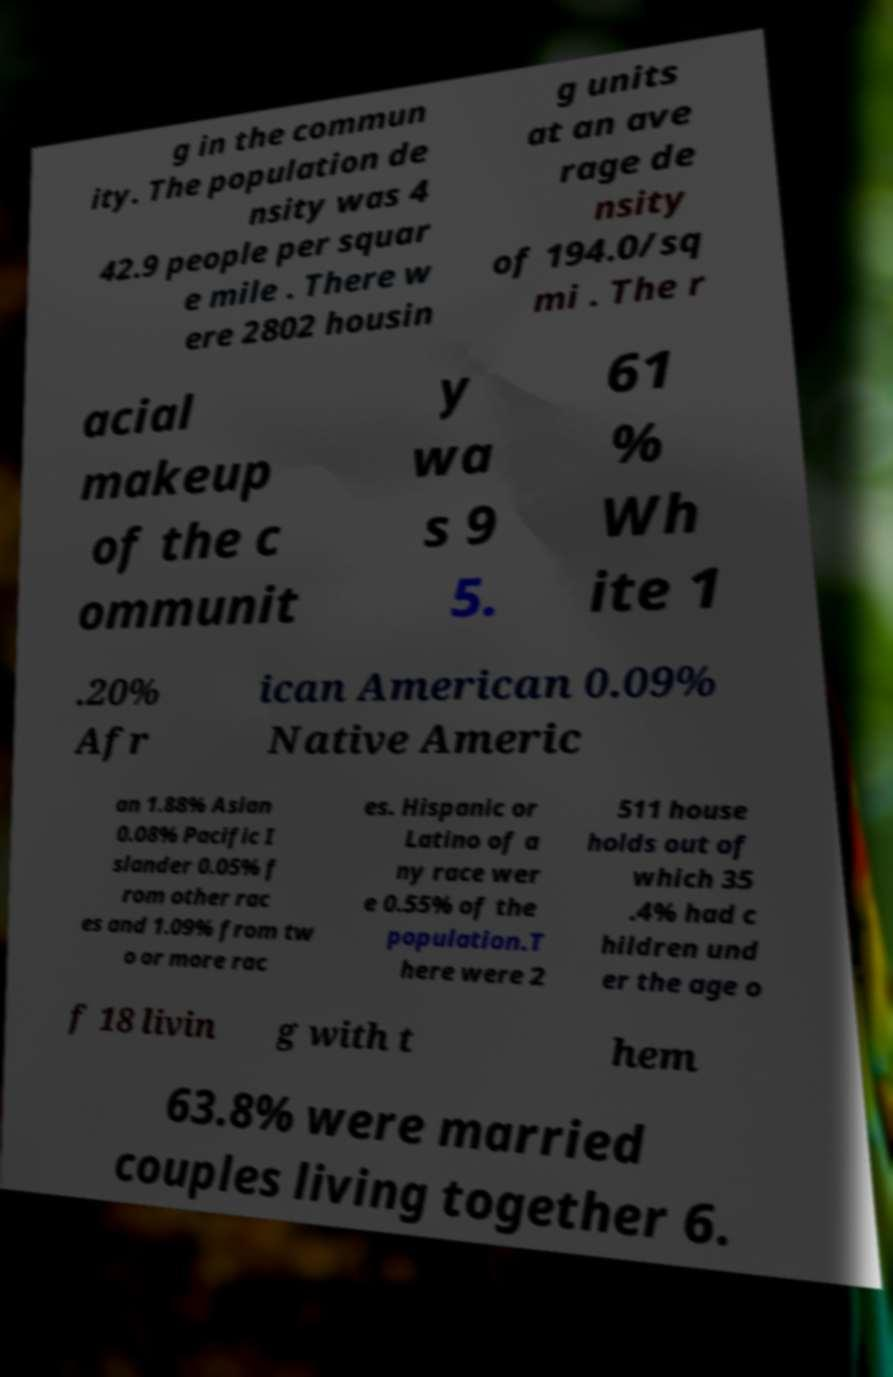For documentation purposes, I need the text within this image transcribed. Could you provide that? g in the commun ity. The population de nsity was 4 42.9 people per squar e mile . There w ere 2802 housin g units at an ave rage de nsity of 194.0/sq mi . The r acial makeup of the c ommunit y wa s 9 5. 61 % Wh ite 1 .20% Afr ican American 0.09% Native Americ an 1.88% Asian 0.08% Pacific I slander 0.05% f rom other rac es and 1.09% from tw o or more rac es. Hispanic or Latino of a ny race wer e 0.55% of the population.T here were 2 511 house holds out of which 35 .4% had c hildren und er the age o f 18 livin g with t hem 63.8% were married couples living together 6. 